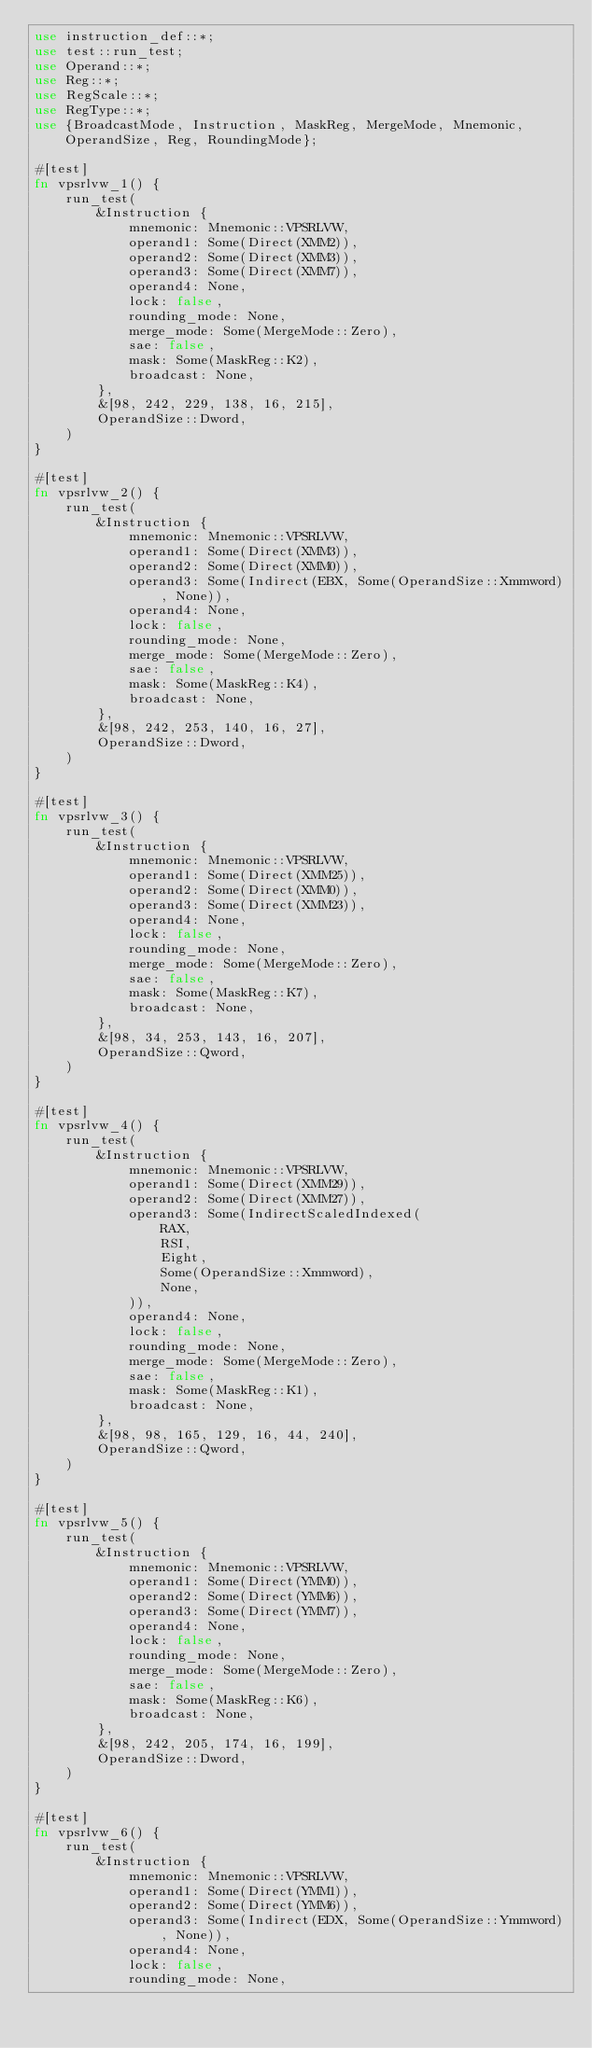Convert code to text. <code><loc_0><loc_0><loc_500><loc_500><_Rust_>use instruction_def::*;
use test::run_test;
use Operand::*;
use Reg::*;
use RegScale::*;
use RegType::*;
use {BroadcastMode, Instruction, MaskReg, MergeMode, Mnemonic, OperandSize, Reg, RoundingMode};

#[test]
fn vpsrlvw_1() {
    run_test(
        &Instruction {
            mnemonic: Mnemonic::VPSRLVW,
            operand1: Some(Direct(XMM2)),
            operand2: Some(Direct(XMM3)),
            operand3: Some(Direct(XMM7)),
            operand4: None,
            lock: false,
            rounding_mode: None,
            merge_mode: Some(MergeMode::Zero),
            sae: false,
            mask: Some(MaskReg::K2),
            broadcast: None,
        },
        &[98, 242, 229, 138, 16, 215],
        OperandSize::Dword,
    )
}

#[test]
fn vpsrlvw_2() {
    run_test(
        &Instruction {
            mnemonic: Mnemonic::VPSRLVW,
            operand1: Some(Direct(XMM3)),
            operand2: Some(Direct(XMM0)),
            operand3: Some(Indirect(EBX, Some(OperandSize::Xmmword), None)),
            operand4: None,
            lock: false,
            rounding_mode: None,
            merge_mode: Some(MergeMode::Zero),
            sae: false,
            mask: Some(MaskReg::K4),
            broadcast: None,
        },
        &[98, 242, 253, 140, 16, 27],
        OperandSize::Dword,
    )
}

#[test]
fn vpsrlvw_3() {
    run_test(
        &Instruction {
            mnemonic: Mnemonic::VPSRLVW,
            operand1: Some(Direct(XMM25)),
            operand2: Some(Direct(XMM0)),
            operand3: Some(Direct(XMM23)),
            operand4: None,
            lock: false,
            rounding_mode: None,
            merge_mode: Some(MergeMode::Zero),
            sae: false,
            mask: Some(MaskReg::K7),
            broadcast: None,
        },
        &[98, 34, 253, 143, 16, 207],
        OperandSize::Qword,
    )
}

#[test]
fn vpsrlvw_4() {
    run_test(
        &Instruction {
            mnemonic: Mnemonic::VPSRLVW,
            operand1: Some(Direct(XMM29)),
            operand2: Some(Direct(XMM27)),
            operand3: Some(IndirectScaledIndexed(
                RAX,
                RSI,
                Eight,
                Some(OperandSize::Xmmword),
                None,
            )),
            operand4: None,
            lock: false,
            rounding_mode: None,
            merge_mode: Some(MergeMode::Zero),
            sae: false,
            mask: Some(MaskReg::K1),
            broadcast: None,
        },
        &[98, 98, 165, 129, 16, 44, 240],
        OperandSize::Qword,
    )
}

#[test]
fn vpsrlvw_5() {
    run_test(
        &Instruction {
            mnemonic: Mnemonic::VPSRLVW,
            operand1: Some(Direct(YMM0)),
            operand2: Some(Direct(YMM6)),
            operand3: Some(Direct(YMM7)),
            operand4: None,
            lock: false,
            rounding_mode: None,
            merge_mode: Some(MergeMode::Zero),
            sae: false,
            mask: Some(MaskReg::K6),
            broadcast: None,
        },
        &[98, 242, 205, 174, 16, 199],
        OperandSize::Dword,
    )
}

#[test]
fn vpsrlvw_6() {
    run_test(
        &Instruction {
            mnemonic: Mnemonic::VPSRLVW,
            operand1: Some(Direct(YMM1)),
            operand2: Some(Direct(YMM6)),
            operand3: Some(Indirect(EDX, Some(OperandSize::Ymmword), None)),
            operand4: None,
            lock: false,
            rounding_mode: None,</code> 